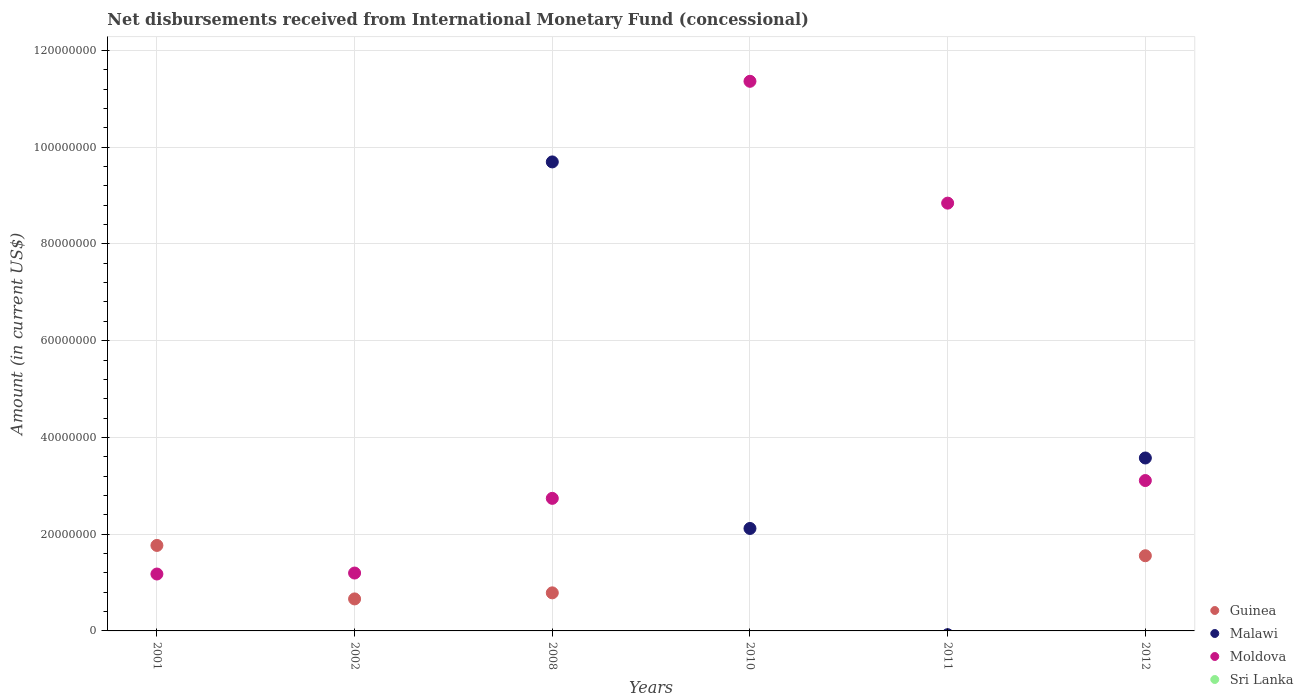How many different coloured dotlines are there?
Offer a terse response. 3. What is the amount of disbursements received from International Monetary Fund in Guinea in 2008?
Your answer should be compact. 7.87e+06. Across all years, what is the maximum amount of disbursements received from International Monetary Fund in Malawi?
Your response must be concise. 9.70e+07. In which year was the amount of disbursements received from International Monetary Fund in Moldova maximum?
Provide a succinct answer. 2010. What is the total amount of disbursements received from International Monetary Fund in Malawi in the graph?
Provide a short and direct response. 1.54e+08. What is the difference between the amount of disbursements received from International Monetary Fund in Moldova in 2008 and that in 2011?
Provide a short and direct response. -6.10e+07. What is the difference between the amount of disbursements received from International Monetary Fund in Sri Lanka in 2002 and the amount of disbursements received from International Monetary Fund in Malawi in 2008?
Give a very brief answer. -9.70e+07. What is the average amount of disbursements received from International Monetary Fund in Guinea per year?
Your response must be concise. 7.95e+06. In the year 2010, what is the difference between the amount of disbursements received from International Monetary Fund in Moldova and amount of disbursements received from International Monetary Fund in Malawi?
Offer a very short reply. 9.24e+07. In how many years, is the amount of disbursements received from International Monetary Fund in Moldova greater than 92000000 US$?
Provide a short and direct response. 1. What is the ratio of the amount of disbursements received from International Monetary Fund in Malawi in 2008 to that in 2012?
Your answer should be very brief. 2.71. Is the amount of disbursements received from International Monetary Fund in Moldova in 2008 less than that in 2012?
Your response must be concise. Yes. What is the difference between the highest and the second highest amount of disbursements received from International Monetary Fund in Guinea?
Ensure brevity in your answer.  2.13e+06. What is the difference between the highest and the lowest amount of disbursements received from International Monetary Fund in Guinea?
Provide a succinct answer. 1.77e+07. In how many years, is the amount of disbursements received from International Monetary Fund in Moldova greater than the average amount of disbursements received from International Monetary Fund in Moldova taken over all years?
Give a very brief answer. 2. Is it the case that in every year, the sum of the amount of disbursements received from International Monetary Fund in Moldova and amount of disbursements received from International Monetary Fund in Guinea  is greater than the sum of amount of disbursements received from International Monetary Fund in Sri Lanka and amount of disbursements received from International Monetary Fund in Malawi?
Provide a succinct answer. No. Is it the case that in every year, the sum of the amount of disbursements received from International Monetary Fund in Guinea and amount of disbursements received from International Monetary Fund in Sri Lanka  is greater than the amount of disbursements received from International Monetary Fund in Moldova?
Give a very brief answer. No. Is the amount of disbursements received from International Monetary Fund in Sri Lanka strictly greater than the amount of disbursements received from International Monetary Fund in Moldova over the years?
Your answer should be compact. No. Is the amount of disbursements received from International Monetary Fund in Guinea strictly less than the amount of disbursements received from International Monetary Fund in Sri Lanka over the years?
Your answer should be very brief. No. How many years are there in the graph?
Offer a terse response. 6. What is the difference between two consecutive major ticks on the Y-axis?
Ensure brevity in your answer.  2.00e+07. Are the values on the major ticks of Y-axis written in scientific E-notation?
Provide a succinct answer. No. Does the graph contain any zero values?
Your answer should be very brief. Yes. How many legend labels are there?
Offer a terse response. 4. What is the title of the graph?
Offer a terse response. Net disbursements received from International Monetary Fund (concessional). Does "Somalia" appear as one of the legend labels in the graph?
Ensure brevity in your answer.  No. What is the Amount (in current US$) of Guinea in 2001?
Give a very brief answer. 1.77e+07. What is the Amount (in current US$) of Malawi in 2001?
Keep it short and to the point. 0. What is the Amount (in current US$) of Moldova in 2001?
Offer a terse response. 1.18e+07. What is the Amount (in current US$) in Guinea in 2002?
Offer a terse response. 6.62e+06. What is the Amount (in current US$) of Moldova in 2002?
Your answer should be compact. 1.20e+07. What is the Amount (in current US$) of Sri Lanka in 2002?
Provide a succinct answer. 0. What is the Amount (in current US$) of Guinea in 2008?
Offer a terse response. 7.87e+06. What is the Amount (in current US$) of Malawi in 2008?
Offer a terse response. 9.70e+07. What is the Amount (in current US$) in Moldova in 2008?
Your response must be concise. 2.74e+07. What is the Amount (in current US$) in Malawi in 2010?
Your answer should be compact. 2.12e+07. What is the Amount (in current US$) of Moldova in 2010?
Provide a short and direct response. 1.14e+08. What is the Amount (in current US$) in Sri Lanka in 2010?
Your answer should be very brief. 0. What is the Amount (in current US$) in Guinea in 2011?
Offer a terse response. 0. What is the Amount (in current US$) in Moldova in 2011?
Provide a short and direct response. 8.84e+07. What is the Amount (in current US$) in Guinea in 2012?
Your answer should be compact. 1.55e+07. What is the Amount (in current US$) of Malawi in 2012?
Provide a short and direct response. 3.57e+07. What is the Amount (in current US$) of Moldova in 2012?
Make the answer very short. 3.11e+07. Across all years, what is the maximum Amount (in current US$) in Guinea?
Keep it short and to the point. 1.77e+07. Across all years, what is the maximum Amount (in current US$) in Malawi?
Provide a short and direct response. 9.70e+07. Across all years, what is the maximum Amount (in current US$) of Moldova?
Provide a short and direct response. 1.14e+08. Across all years, what is the minimum Amount (in current US$) in Moldova?
Your answer should be compact. 1.18e+07. What is the total Amount (in current US$) of Guinea in the graph?
Your answer should be compact. 4.77e+07. What is the total Amount (in current US$) of Malawi in the graph?
Provide a short and direct response. 1.54e+08. What is the total Amount (in current US$) in Moldova in the graph?
Give a very brief answer. 2.84e+08. What is the difference between the Amount (in current US$) in Guinea in 2001 and that in 2002?
Your response must be concise. 1.11e+07. What is the difference between the Amount (in current US$) in Moldova in 2001 and that in 2002?
Your answer should be very brief. -2.02e+05. What is the difference between the Amount (in current US$) in Guinea in 2001 and that in 2008?
Make the answer very short. 9.80e+06. What is the difference between the Amount (in current US$) of Moldova in 2001 and that in 2008?
Provide a succinct answer. -1.56e+07. What is the difference between the Amount (in current US$) of Moldova in 2001 and that in 2010?
Your response must be concise. -1.02e+08. What is the difference between the Amount (in current US$) of Moldova in 2001 and that in 2011?
Your answer should be very brief. -7.67e+07. What is the difference between the Amount (in current US$) of Guinea in 2001 and that in 2012?
Offer a very short reply. 2.13e+06. What is the difference between the Amount (in current US$) in Moldova in 2001 and that in 2012?
Offer a very short reply. -1.93e+07. What is the difference between the Amount (in current US$) in Guinea in 2002 and that in 2008?
Your answer should be compact. -1.25e+06. What is the difference between the Amount (in current US$) of Moldova in 2002 and that in 2008?
Keep it short and to the point. -1.54e+07. What is the difference between the Amount (in current US$) in Moldova in 2002 and that in 2010?
Provide a short and direct response. -1.02e+08. What is the difference between the Amount (in current US$) of Moldova in 2002 and that in 2011?
Provide a short and direct response. -7.65e+07. What is the difference between the Amount (in current US$) in Guinea in 2002 and that in 2012?
Make the answer very short. -8.92e+06. What is the difference between the Amount (in current US$) in Moldova in 2002 and that in 2012?
Provide a short and direct response. -1.91e+07. What is the difference between the Amount (in current US$) in Malawi in 2008 and that in 2010?
Ensure brevity in your answer.  7.58e+07. What is the difference between the Amount (in current US$) in Moldova in 2008 and that in 2010?
Your answer should be compact. -8.62e+07. What is the difference between the Amount (in current US$) in Moldova in 2008 and that in 2011?
Give a very brief answer. -6.10e+07. What is the difference between the Amount (in current US$) in Guinea in 2008 and that in 2012?
Your answer should be compact. -7.67e+06. What is the difference between the Amount (in current US$) of Malawi in 2008 and that in 2012?
Keep it short and to the point. 6.12e+07. What is the difference between the Amount (in current US$) in Moldova in 2008 and that in 2012?
Give a very brief answer. -3.68e+06. What is the difference between the Amount (in current US$) in Moldova in 2010 and that in 2011?
Give a very brief answer. 2.52e+07. What is the difference between the Amount (in current US$) of Malawi in 2010 and that in 2012?
Provide a short and direct response. -1.46e+07. What is the difference between the Amount (in current US$) of Moldova in 2010 and that in 2012?
Your answer should be compact. 8.25e+07. What is the difference between the Amount (in current US$) of Moldova in 2011 and that in 2012?
Provide a succinct answer. 5.73e+07. What is the difference between the Amount (in current US$) of Guinea in 2001 and the Amount (in current US$) of Moldova in 2002?
Make the answer very short. 5.71e+06. What is the difference between the Amount (in current US$) of Guinea in 2001 and the Amount (in current US$) of Malawi in 2008?
Give a very brief answer. -7.93e+07. What is the difference between the Amount (in current US$) in Guinea in 2001 and the Amount (in current US$) in Moldova in 2008?
Provide a short and direct response. -9.73e+06. What is the difference between the Amount (in current US$) in Guinea in 2001 and the Amount (in current US$) in Malawi in 2010?
Provide a succinct answer. -3.51e+06. What is the difference between the Amount (in current US$) of Guinea in 2001 and the Amount (in current US$) of Moldova in 2010?
Offer a very short reply. -9.59e+07. What is the difference between the Amount (in current US$) of Guinea in 2001 and the Amount (in current US$) of Moldova in 2011?
Your answer should be very brief. -7.08e+07. What is the difference between the Amount (in current US$) of Guinea in 2001 and the Amount (in current US$) of Malawi in 2012?
Your answer should be compact. -1.81e+07. What is the difference between the Amount (in current US$) in Guinea in 2001 and the Amount (in current US$) in Moldova in 2012?
Keep it short and to the point. -1.34e+07. What is the difference between the Amount (in current US$) of Guinea in 2002 and the Amount (in current US$) of Malawi in 2008?
Your answer should be very brief. -9.03e+07. What is the difference between the Amount (in current US$) of Guinea in 2002 and the Amount (in current US$) of Moldova in 2008?
Provide a succinct answer. -2.08e+07. What is the difference between the Amount (in current US$) of Guinea in 2002 and the Amount (in current US$) of Malawi in 2010?
Provide a short and direct response. -1.46e+07. What is the difference between the Amount (in current US$) in Guinea in 2002 and the Amount (in current US$) in Moldova in 2010?
Keep it short and to the point. -1.07e+08. What is the difference between the Amount (in current US$) in Guinea in 2002 and the Amount (in current US$) in Moldova in 2011?
Make the answer very short. -8.18e+07. What is the difference between the Amount (in current US$) of Guinea in 2002 and the Amount (in current US$) of Malawi in 2012?
Offer a very short reply. -2.91e+07. What is the difference between the Amount (in current US$) of Guinea in 2002 and the Amount (in current US$) of Moldova in 2012?
Your answer should be compact. -2.45e+07. What is the difference between the Amount (in current US$) in Guinea in 2008 and the Amount (in current US$) in Malawi in 2010?
Ensure brevity in your answer.  -1.33e+07. What is the difference between the Amount (in current US$) in Guinea in 2008 and the Amount (in current US$) in Moldova in 2010?
Your answer should be compact. -1.06e+08. What is the difference between the Amount (in current US$) in Malawi in 2008 and the Amount (in current US$) in Moldova in 2010?
Give a very brief answer. -1.67e+07. What is the difference between the Amount (in current US$) of Guinea in 2008 and the Amount (in current US$) of Moldova in 2011?
Your answer should be very brief. -8.06e+07. What is the difference between the Amount (in current US$) of Malawi in 2008 and the Amount (in current US$) of Moldova in 2011?
Your answer should be compact. 8.52e+06. What is the difference between the Amount (in current US$) in Guinea in 2008 and the Amount (in current US$) in Malawi in 2012?
Provide a short and direct response. -2.79e+07. What is the difference between the Amount (in current US$) of Guinea in 2008 and the Amount (in current US$) of Moldova in 2012?
Provide a short and direct response. -2.32e+07. What is the difference between the Amount (in current US$) in Malawi in 2008 and the Amount (in current US$) in Moldova in 2012?
Keep it short and to the point. 6.59e+07. What is the difference between the Amount (in current US$) of Malawi in 2010 and the Amount (in current US$) of Moldova in 2011?
Provide a succinct answer. -6.73e+07. What is the difference between the Amount (in current US$) of Malawi in 2010 and the Amount (in current US$) of Moldova in 2012?
Your answer should be very brief. -9.91e+06. What is the average Amount (in current US$) in Guinea per year?
Your answer should be very brief. 7.95e+06. What is the average Amount (in current US$) in Malawi per year?
Ensure brevity in your answer.  2.56e+07. What is the average Amount (in current US$) of Moldova per year?
Your response must be concise. 4.74e+07. In the year 2001, what is the difference between the Amount (in current US$) in Guinea and Amount (in current US$) in Moldova?
Offer a terse response. 5.91e+06. In the year 2002, what is the difference between the Amount (in current US$) in Guinea and Amount (in current US$) in Moldova?
Keep it short and to the point. -5.35e+06. In the year 2008, what is the difference between the Amount (in current US$) in Guinea and Amount (in current US$) in Malawi?
Your response must be concise. -8.91e+07. In the year 2008, what is the difference between the Amount (in current US$) of Guinea and Amount (in current US$) of Moldova?
Your answer should be compact. -1.95e+07. In the year 2008, what is the difference between the Amount (in current US$) of Malawi and Amount (in current US$) of Moldova?
Your answer should be compact. 6.95e+07. In the year 2010, what is the difference between the Amount (in current US$) of Malawi and Amount (in current US$) of Moldova?
Make the answer very short. -9.24e+07. In the year 2012, what is the difference between the Amount (in current US$) of Guinea and Amount (in current US$) of Malawi?
Give a very brief answer. -2.02e+07. In the year 2012, what is the difference between the Amount (in current US$) of Guinea and Amount (in current US$) of Moldova?
Provide a short and direct response. -1.55e+07. In the year 2012, what is the difference between the Amount (in current US$) in Malawi and Amount (in current US$) in Moldova?
Your answer should be compact. 4.66e+06. What is the ratio of the Amount (in current US$) in Guinea in 2001 to that in 2002?
Give a very brief answer. 2.67. What is the ratio of the Amount (in current US$) in Moldova in 2001 to that in 2002?
Your answer should be compact. 0.98. What is the ratio of the Amount (in current US$) of Guinea in 2001 to that in 2008?
Offer a very short reply. 2.25. What is the ratio of the Amount (in current US$) of Moldova in 2001 to that in 2008?
Offer a very short reply. 0.43. What is the ratio of the Amount (in current US$) in Moldova in 2001 to that in 2010?
Offer a very short reply. 0.1. What is the ratio of the Amount (in current US$) of Moldova in 2001 to that in 2011?
Ensure brevity in your answer.  0.13. What is the ratio of the Amount (in current US$) in Guinea in 2001 to that in 2012?
Your response must be concise. 1.14. What is the ratio of the Amount (in current US$) of Moldova in 2001 to that in 2012?
Provide a short and direct response. 0.38. What is the ratio of the Amount (in current US$) in Guinea in 2002 to that in 2008?
Keep it short and to the point. 0.84. What is the ratio of the Amount (in current US$) of Moldova in 2002 to that in 2008?
Ensure brevity in your answer.  0.44. What is the ratio of the Amount (in current US$) of Moldova in 2002 to that in 2010?
Make the answer very short. 0.11. What is the ratio of the Amount (in current US$) in Moldova in 2002 to that in 2011?
Give a very brief answer. 0.14. What is the ratio of the Amount (in current US$) of Guinea in 2002 to that in 2012?
Provide a succinct answer. 0.43. What is the ratio of the Amount (in current US$) of Moldova in 2002 to that in 2012?
Provide a succinct answer. 0.38. What is the ratio of the Amount (in current US$) in Malawi in 2008 to that in 2010?
Offer a very short reply. 4.58. What is the ratio of the Amount (in current US$) of Moldova in 2008 to that in 2010?
Your response must be concise. 0.24. What is the ratio of the Amount (in current US$) in Moldova in 2008 to that in 2011?
Give a very brief answer. 0.31. What is the ratio of the Amount (in current US$) in Guinea in 2008 to that in 2012?
Your answer should be very brief. 0.51. What is the ratio of the Amount (in current US$) of Malawi in 2008 to that in 2012?
Make the answer very short. 2.71. What is the ratio of the Amount (in current US$) in Moldova in 2008 to that in 2012?
Keep it short and to the point. 0.88. What is the ratio of the Amount (in current US$) in Moldova in 2010 to that in 2011?
Your response must be concise. 1.28. What is the ratio of the Amount (in current US$) in Malawi in 2010 to that in 2012?
Ensure brevity in your answer.  0.59. What is the ratio of the Amount (in current US$) in Moldova in 2010 to that in 2012?
Ensure brevity in your answer.  3.65. What is the ratio of the Amount (in current US$) in Moldova in 2011 to that in 2012?
Make the answer very short. 2.84. What is the difference between the highest and the second highest Amount (in current US$) in Guinea?
Give a very brief answer. 2.13e+06. What is the difference between the highest and the second highest Amount (in current US$) in Malawi?
Give a very brief answer. 6.12e+07. What is the difference between the highest and the second highest Amount (in current US$) of Moldova?
Provide a short and direct response. 2.52e+07. What is the difference between the highest and the lowest Amount (in current US$) of Guinea?
Your answer should be very brief. 1.77e+07. What is the difference between the highest and the lowest Amount (in current US$) in Malawi?
Make the answer very short. 9.70e+07. What is the difference between the highest and the lowest Amount (in current US$) of Moldova?
Provide a succinct answer. 1.02e+08. 